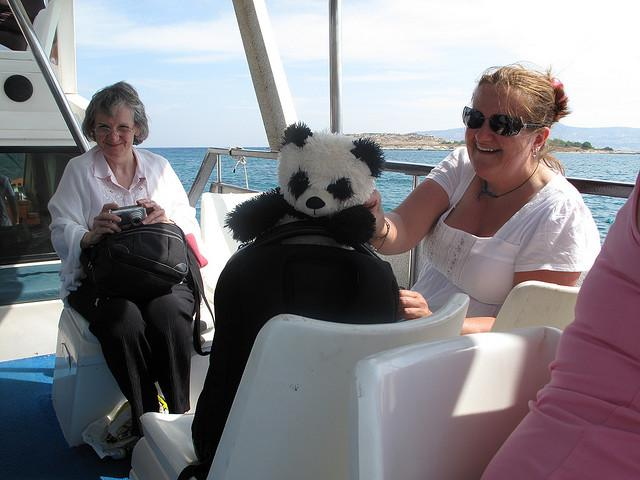What digital device is being used to capture memories?

Choices:
A) recorder
B) phone
C) sketch artist
D) camera camera 